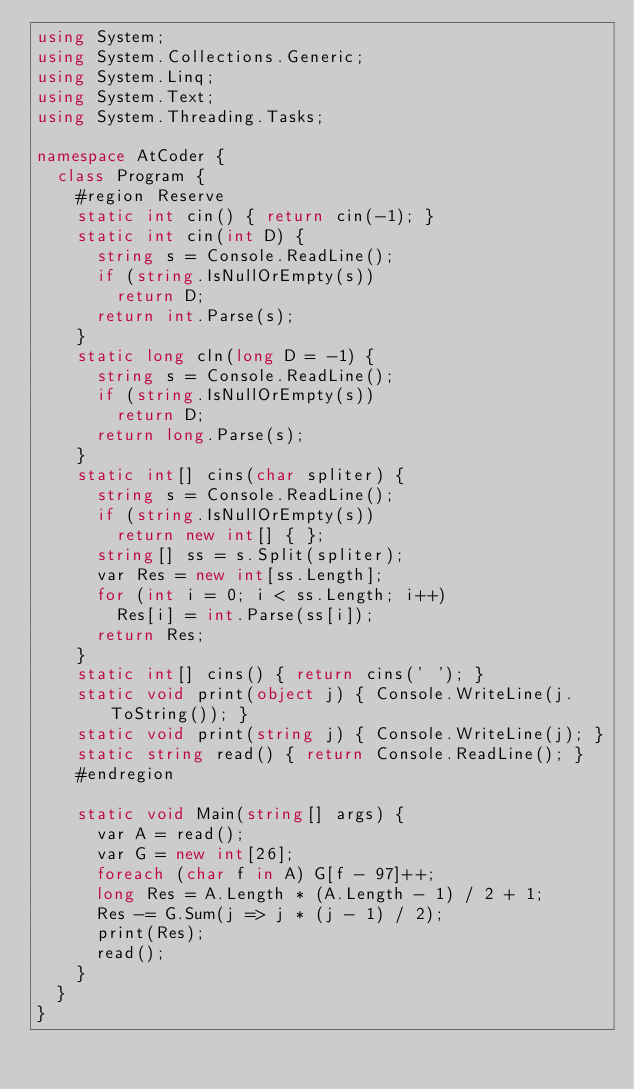Convert code to text. <code><loc_0><loc_0><loc_500><loc_500><_C#_>using System;
using System.Collections.Generic;
using System.Linq;
using System.Text;
using System.Threading.Tasks;

namespace AtCoder {
	class Program {
		#region Reserve
		static int cin() { return cin(-1); }
		static int cin(int D) {
			string s = Console.ReadLine();
			if (string.IsNullOrEmpty(s))
				return D;
			return int.Parse(s);
		}
		static long cln(long D = -1) {
			string s = Console.ReadLine();
			if (string.IsNullOrEmpty(s))
				return D;
			return long.Parse(s);
		}
		static int[] cins(char spliter) {
			string s = Console.ReadLine();
			if (string.IsNullOrEmpty(s))
				return new int[] { };
			string[] ss = s.Split(spliter);
			var Res = new int[ss.Length];
			for (int i = 0; i < ss.Length; i++)
				Res[i] = int.Parse(ss[i]);
			return Res;
		}
		static int[] cins() { return cins(' '); }
		static void print(object j) { Console.WriteLine(j.ToString()); }
		static void print(string j) { Console.WriteLine(j); }
		static string read() { return Console.ReadLine(); }
		#endregion

		static void Main(string[] args) {
			var A = read();
			var G = new int[26];
			foreach (char f in A) G[f - 97]++;
			long Res = A.Length * (A.Length - 1) / 2 + 1;
			Res -= G.Sum(j => j * (j - 1) / 2);
			print(Res);
			read();
		}
	}
}
</code> 